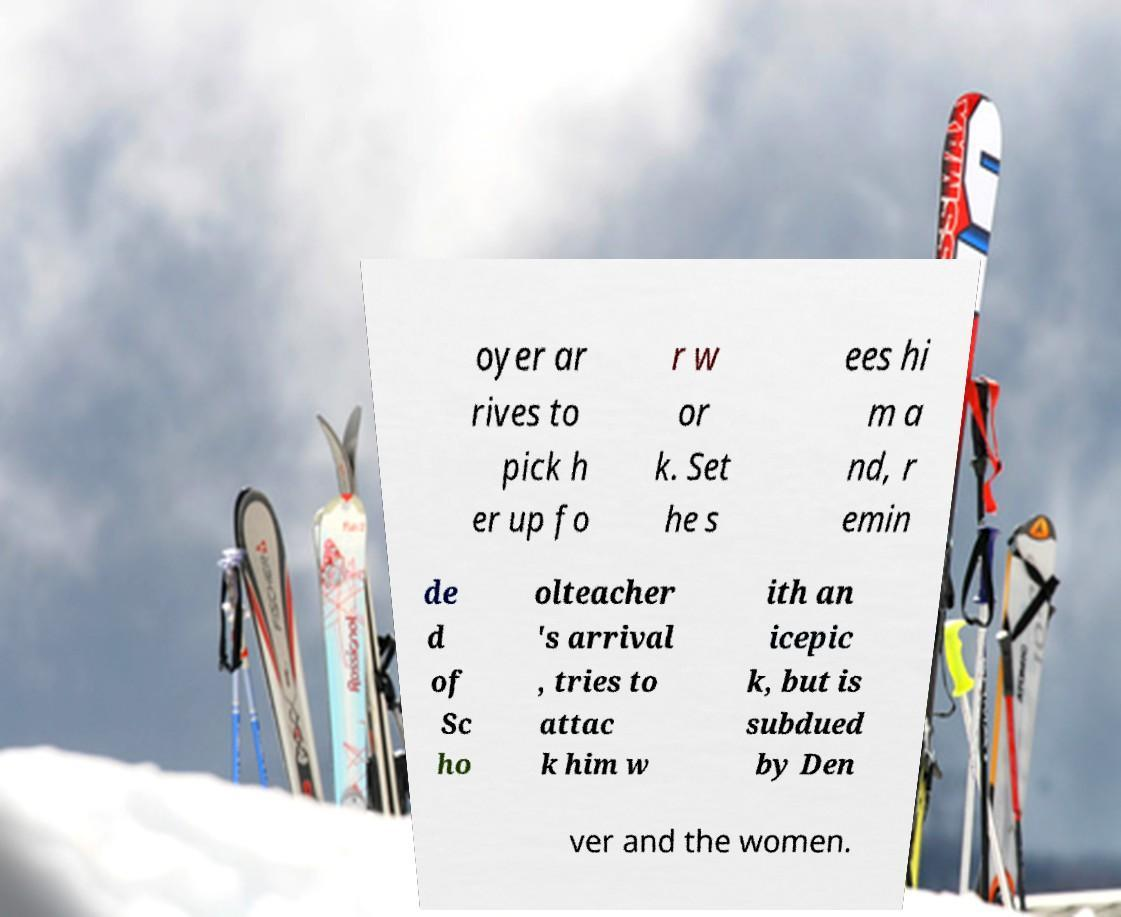Please read and relay the text visible in this image. What does it say? oyer ar rives to pick h er up fo r w or k. Set he s ees hi m a nd, r emin de d of Sc ho olteacher 's arrival , tries to attac k him w ith an icepic k, but is subdued by Den ver and the women. 